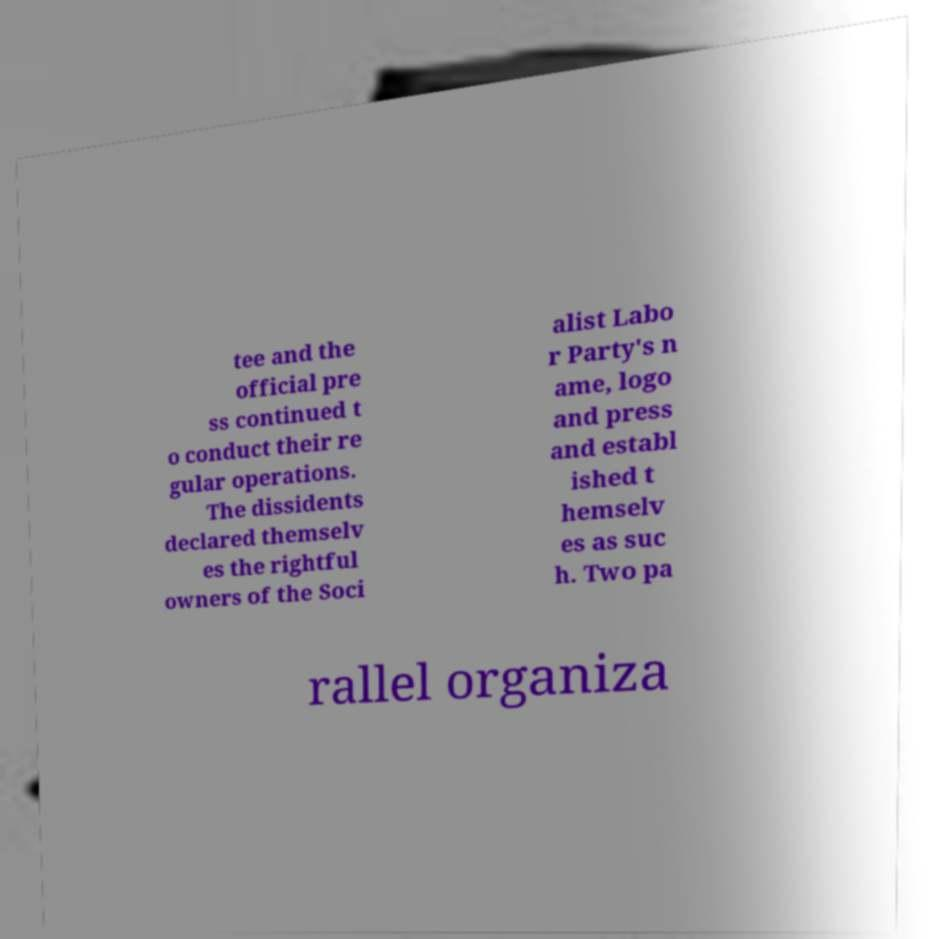What messages or text are displayed in this image? I need them in a readable, typed format. tee and the official pre ss continued t o conduct their re gular operations. The dissidents declared themselv es the rightful owners of the Soci alist Labo r Party's n ame, logo and press and establ ished t hemselv es as suc h. Two pa rallel organiza 